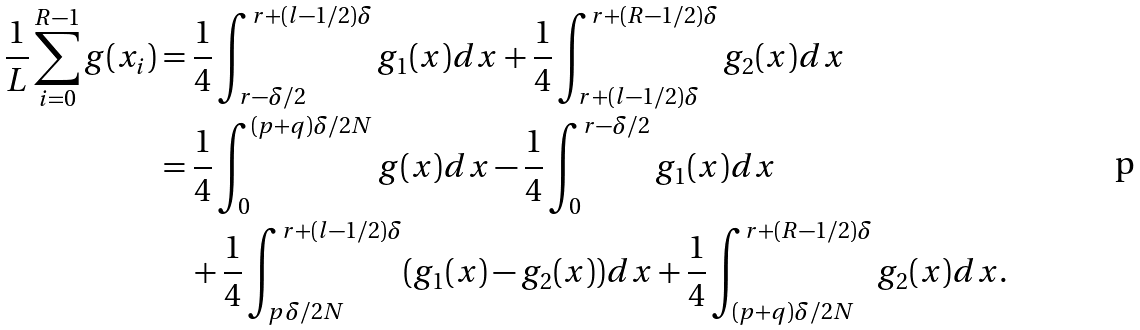<formula> <loc_0><loc_0><loc_500><loc_500>\frac { 1 } { L } \sum _ { i = 0 } ^ { R - 1 } g ( x _ { i } ) & = \frac { 1 } { 4 } \int _ { r - \delta / 2 } ^ { r + ( l - 1 / 2 ) \delta } g _ { 1 } ( x ) d x + \frac { 1 } { 4 } \int _ { r + ( l - 1 / 2 ) \delta } ^ { r + ( R - 1 / 2 ) \delta } g _ { 2 } ( x ) d x \\ & = \frac { 1 } { 4 } \int _ { 0 } ^ { ( p + q ) \delta / 2 N } g ( x ) d x - \frac { 1 } { 4 } \int _ { 0 } ^ { r - \delta / 2 } g _ { 1 } ( x ) d x \\ & \quad + \frac { 1 } { 4 } \int _ { p \delta / 2 N } ^ { r + ( l - 1 / 2 ) \delta } ( g _ { 1 } ( x ) - g _ { 2 } ( x ) ) d x + \frac { 1 } { 4 } \int _ { ( p + q ) \delta / 2 N } ^ { r + ( R - 1 / 2 ) \delta } g _ { 2 } ( x ) d x .</formula> 